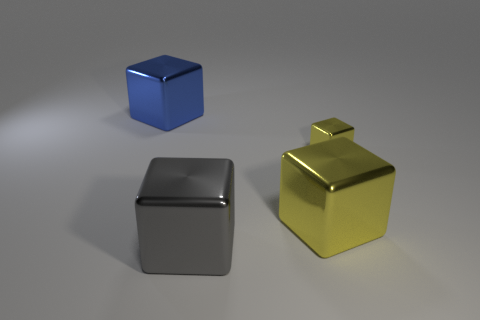Subtract all big metal cubes. How many cubes are left? 1 Add 3 gray shiny blocks. How many objects exist? 7 Subtract all cyan spheres. How many yellow cubes are left? 2 Subtract 4 blocks. How many blocks are left? 0 Subtract all gray cubes. How many cubes are left? 3 Subtract all big blue metallic things. Subtract all small shiny objects. How many objects are left? 2 Add 1 gray cubes. How many gray cubes are left? 2 Add 4 tiny metal blocks. How many tiny metal blocks exist? 5 Subtract 0 red spheres. How many objects are left? 4 Subtract all yellow blocks. Subtract all yellow spheres. How many blocks are left? 2 